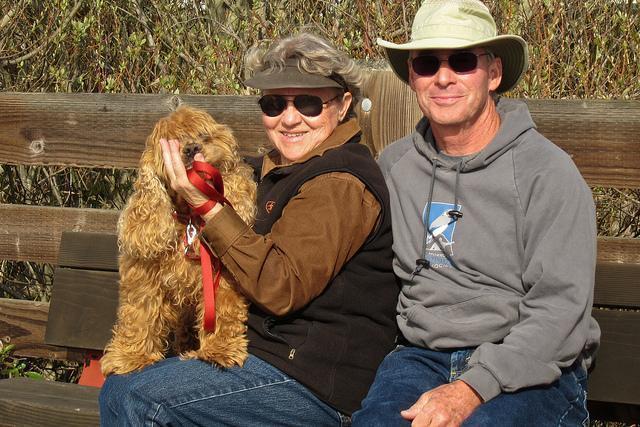What do both people have on?
Indicate the correct choice and explain in the format: 'Answer: answer
Rationale: rationale.'
Options: Crowns, sunglasses, armor, masks. Answer: sunglasses.
Rationale: They have sunglasses. 